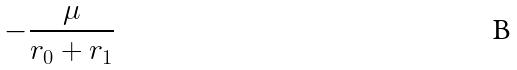Convert formula to latex. <formula><loc_0><loc_0><loc_500><loc_500>- \frac { \mu } { r _ { 0 } + r _ { 1 } }</formula> 